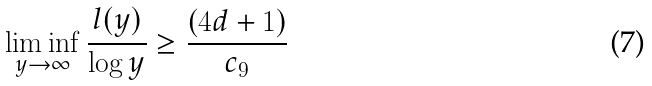<formula> <loc_0><loc_0><loc_500><loc_500>\liminf _ { y \to \infty } \frac { l ( y ) } { \log y } \geq \frac { ( 4 d + 1 ) } { c _ { 9 } } \,</formula> 